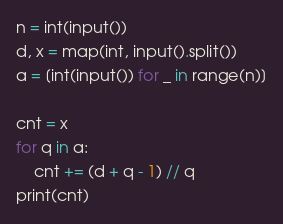<code> <loc_0><loc_0><loc_500><loc_500><_Python_>n = int(input())
d, x = map(int, input().split())
a = [int(input()) for _ in range(n)]

cnt = x
for q in a:
    cnt += (d + q - 1) // q
print(cnt)</code> 